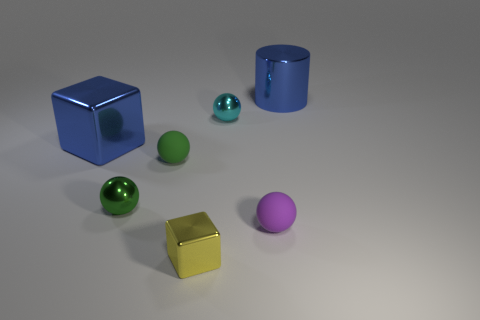Can you describe the textures and materials of the objects on the left? Certainly! The object on the far left is a cube with a metallic, reflective blue surface. Next to it is a green, glossy sphere, also with a metallic sheen. Are there other objects in the scene that share similar materials? Yes, there appears to be another metallic object, which is a cylinder with a shiny blue surface to the right of the scene, sharing a similar material to the blue cube. 